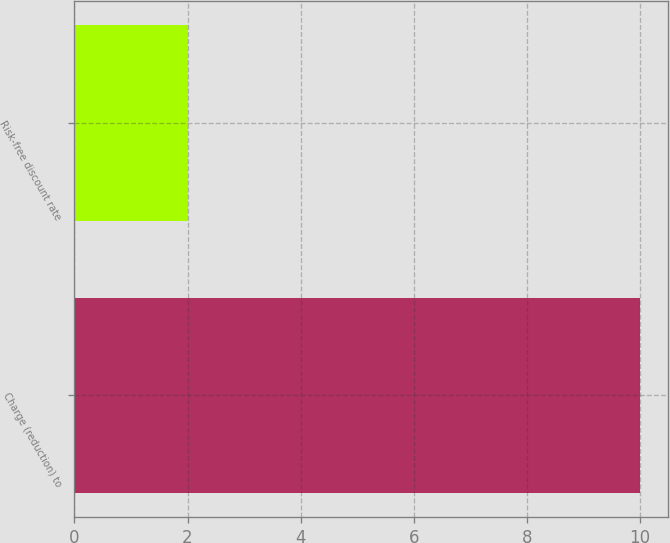Convert chart. <chart><loc_0><loc_0><loc_500><loc_500><bar_chart><fcel>Charge (reduction) to<fcel>Risk-free discount rate<nl><fcel>10<fcel>2<nl></chart> 